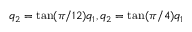Convert formula to latex. <formula><loc_0><loc_0><loc_500><loc_500>q _ { 2 } = \tan ( \pi / 1 2 ) q _ { 1 } , q _ { 2 } = \tan ( \pi / 4 ) q _ { 1 }</formula> 